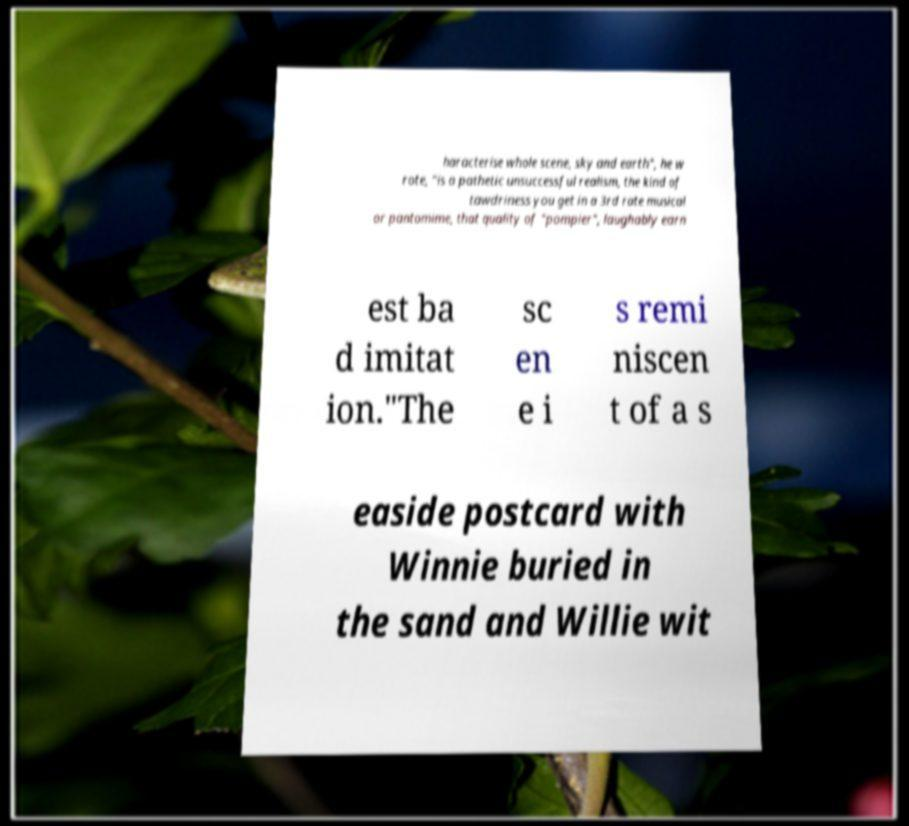Can you accurately transcribe the text from the provided image for me? haracterise whole scene, sky and earth", he w rote, "is a pathetic unsuccessful realism, the kind of tawdriness you get in a 3rd rate musical or pantomime, that quality of "pompier", laughably earn est ba d imitat ion."The sc en e i s remi niscen t of a s easide postcard with Winnie buried in the sand and Willie wit 